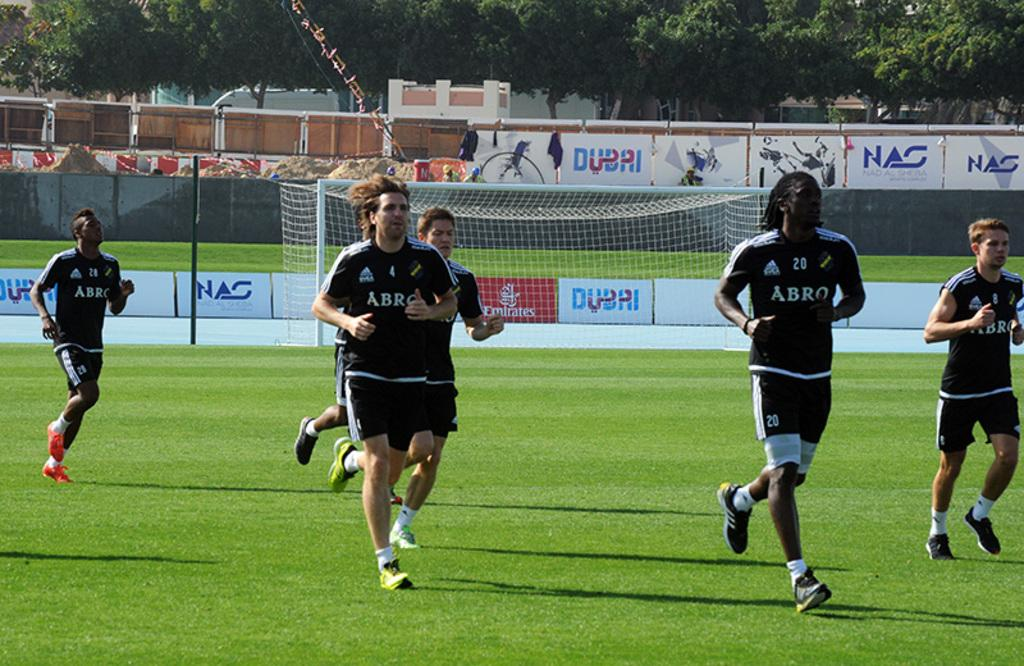<image>
Create a compact narrative representing the image presented. the word abro is on the front of the soccer jersey 